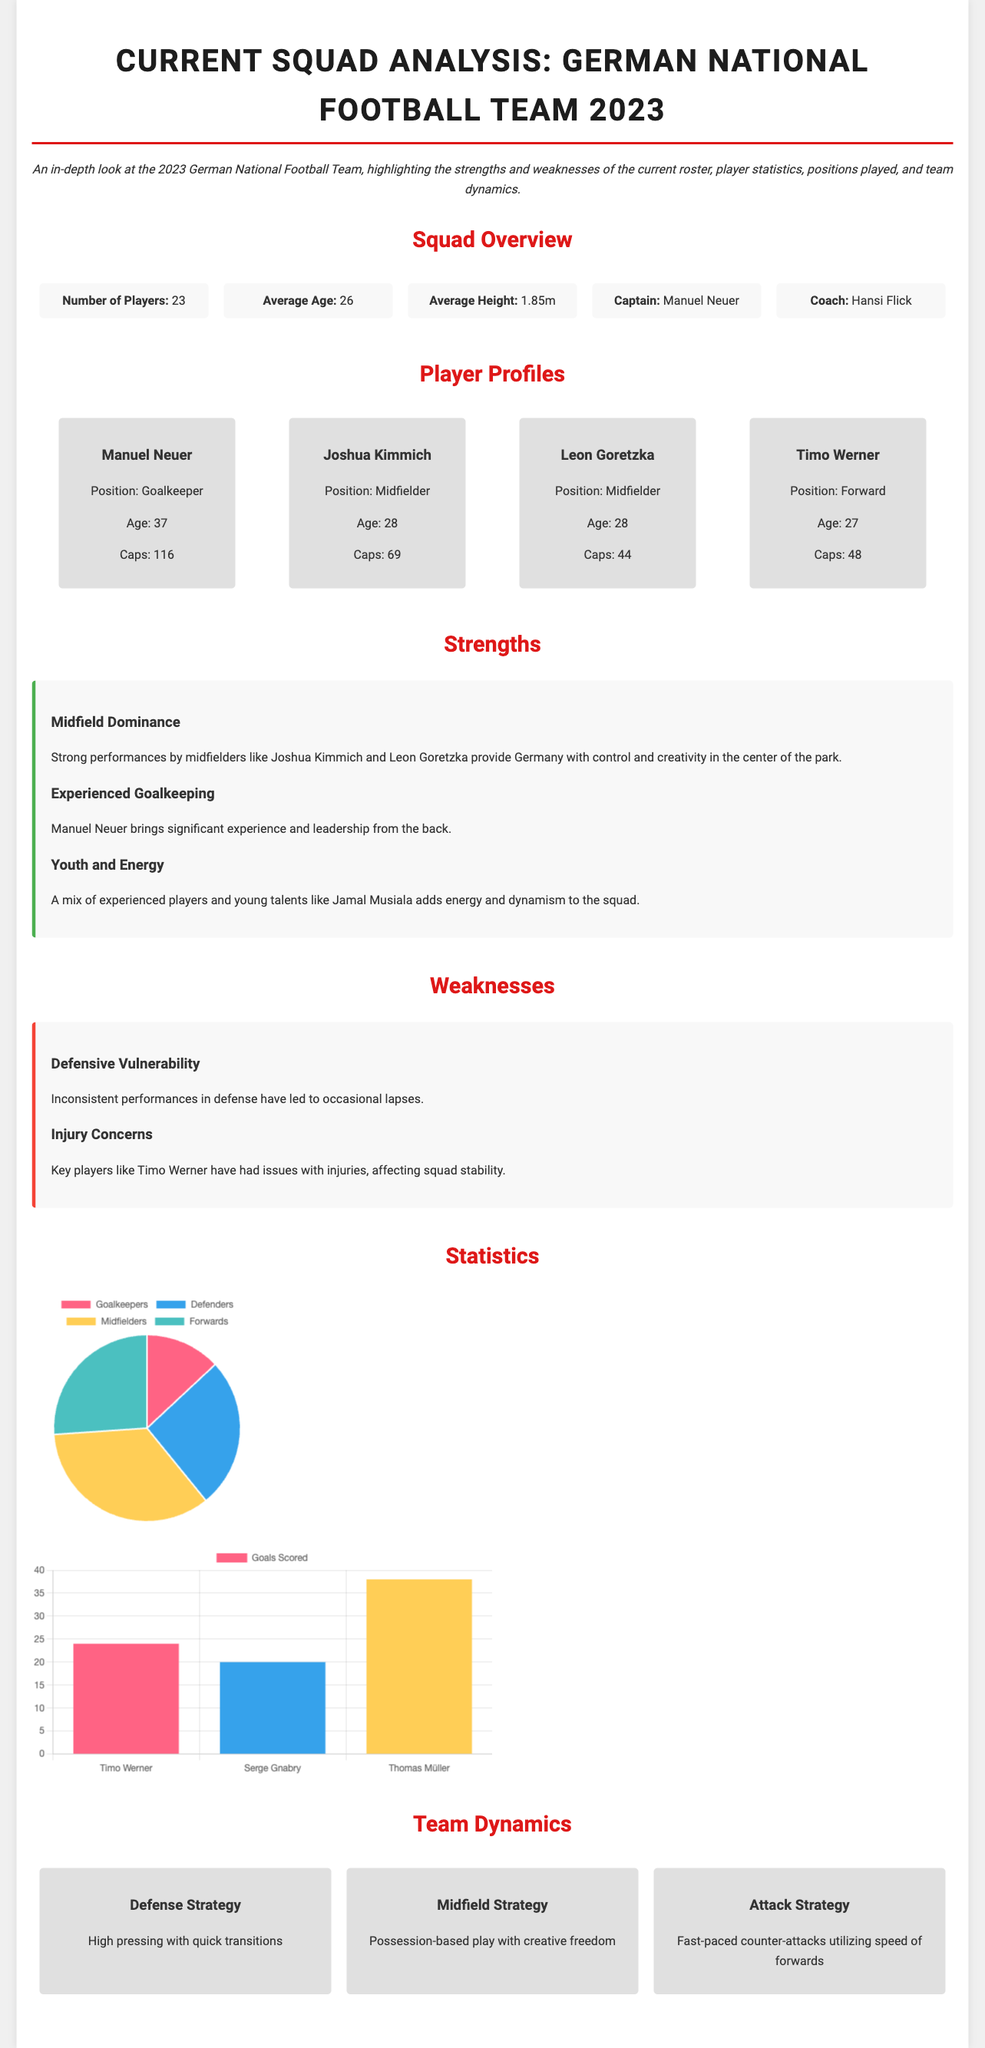What is the average age of the squad? The average age of the squad is displayed directly in the document under "Squad Overview."
Answer: 26 Who is the captain of the team? The captain is listed in the "Squad Overview" section of the document.
Answer: Manuel Neuer How many players are in the current squad? The number of players is stated clearly in the "Squad Overview" section.
Answer: 23 What position does Joshua Kimmich play? Joshua Kimmich's position is noted in his player profile section.
Answer: Midfielder What is Germany's defensive strategy? The defensive strategy is specified under the "Team Dynamics" section.
Answer: High pressing with quick transitions Which player has the highest number of goals scored? The document provides a bar chart showing goals scored by the top players, allowing for easy comparison.
Answer: Thomas Müller What is a notable strength of the current squad? The strengths are listed and described in the "Strengths" section of the document.
Answer: Midfield Dominance What type of chart is used for the positions played? The type of chart is mentioned in the "Statistics" section where the chart is defined.
Answer: Pie Chart Which player has had injuries affecting squad stability? The weaknesses section mentions specific players concerning their injury issues.
Answer: Timo Werner 